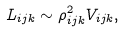<formula> <loc_0><loc_0><loc_500><loc_500>L _ { i j k } \sim \rho _ { i j k } ^ { 2 } V _ { i j k } ,</formula> 